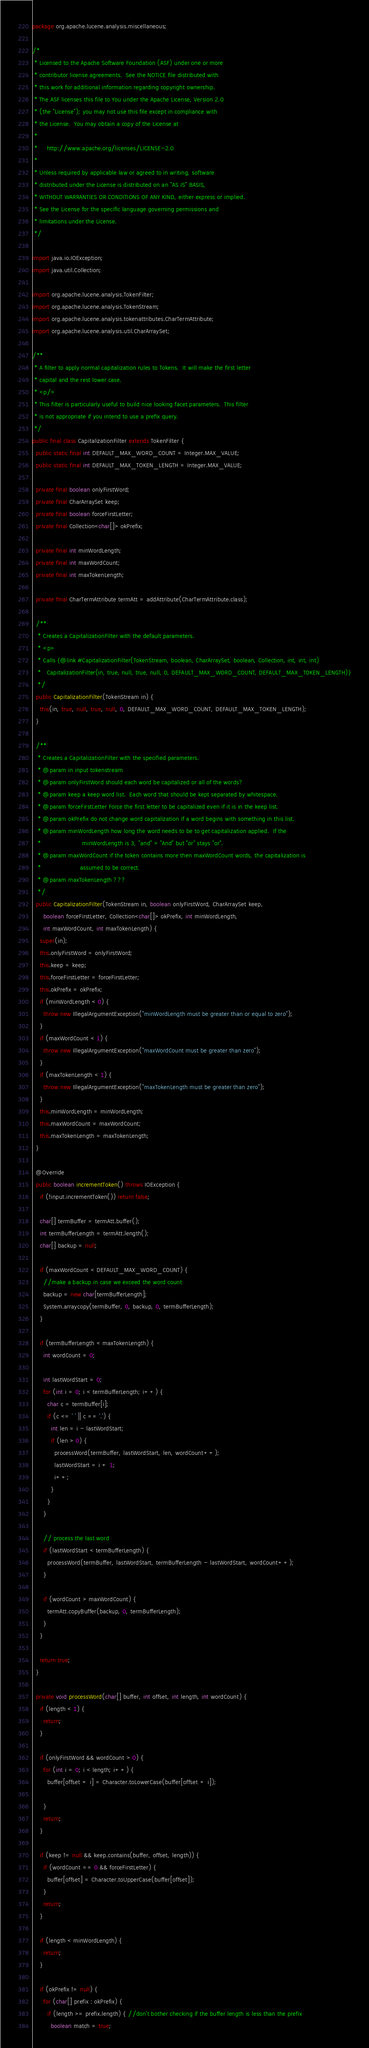Convert code to text. <code><loc_0><loc_0><loc_500><loc_500><_Java_>package org.apache.lucene.analysis.miscellaneous;

/*
 * Licensed to the Apache Software Foundation (ASF) under one or more
 * contributor license agreements.  See the NOTICE file distributed with
 * this work for additional information regarding copyright ownership.
 * The ASF licenses this file to You under the Apache License, Version 2.0
 * (the "License"); you may not use this file except in compliance with
 * the License.  You may obtain a copy of the License at
 *
 *     http://www.apache.org/licenses/LICENSE-2.0
 *
 * Unless required by applicable law or agreed to in writing, software
 * distributed under the License is distributed on an "AS IS" BASIS,
 * WITHOUT WARRANTIES OR CONDITIONS OF ANY KIND, either express or implied.
 * See the License for the specific language governing permissions and
 * limitations under the License.
 */

import java.io.IOException;
import java.util.Collection;

import org.apache.lucene.analysis.TokenFilter;
import org.apache.lucene.analysis.TokenStream;
import org.apache.lucene.analysis.tokenattributes.CharTermAttribute;
import org.apache.lucene.analysis.util.CharArraySet;

/** 
 * A filter to apply normal capitalization rules to Tokens.  It will make the first letter
 * capital and the rest lower case.
 * <p/>
 * This filter is particularly useful to build nice looking facet parameters.  This filter
 * is not appropriate if you intend to use a prefix query.
 */
public final class CapitalizationFilter extends TokenFilter {
  public static final int DEFAULT_MAX_WORD_COUNT = Integer.MAX_VALUE;
  public static final int DEFAULT_MAX_TOKEN_LENGTH = Integer.MAX_VALUE;
  
  private final boolean onlyFirstWord;
  private final CharArraySet keep;
  private final boolean forceFirstLetter;
  private final Collection<char[]> okPrefix;

  private final int minWordLength;
  private final int maxWordCount;
  private final int maxTokenLength;
  
  private final CharTermAttribute termAtt = addAttribute(CharTermAttribute.class);

  /**
   * Creates a CapitalizationFilter with the default parameters.
   * <p>
   * Calls {@link #CapitalizationFilter(TokenStream, boolean, CharArraySet, boolean, Collection, int, int, int)
   *   CapitalizationFilter(in, true, null, true, null, 0, DEFAULT_MAX_WORD_COUNT, DEFAULT_MAX_TOKEN_LENGTH)}
   */
  public CapitalizationFilter(TokenStream in) {
    this(in, true, null, true, null, 0, DEFAULT_MAX_WORD_COUNT, DEFAULT_MAX_TOKEN_LENGTH);
  }
  
  /**
   * Creates a CapitalizationFilter with the specified parameters.
   * @param in input tokenstream 
   * @param onlyFirstWord should each word be capitalized or all of the words?
   * @param keep a keep word list.  Each word that should be kept separated by whitespace.
   * @param forceFirstLetter Force the first letter to be capitalized even if it is in the keep list.
   * @param okPrefix do not change word capitalization if a word begins with something in this list.
   * @param minWordLength how long the word needs to be to get capitalization applied.  If the
   *                      minWordLength is 3, "and" > "And" but "or" stays "or".
   * @param maxWordCount if the token contains more then maxWordCount words, the capitalization is
   *                     assumed to be correct.
   * @param maxTokenLength ???
   */
  public CapitalizationFilter(TokenStream in, boolean onlyFirstWord, CharArraySet keep, 
      boolean forceFirstLetter, Collection<char[]> okPrefix, int minWordLength, 
      int maxWordCount, int maxTokenLength) {
    super(in);
    this.onlyFirstWord = onlyFirstWord;
    this.keep = keep;
    this.forceFirstLetter = forceFirstLetter;
    this.okPrefix = okPrefix;
    if (minWordLength < 0) {
      throw new IllegalArgumentException("minWordLength must be greater than or equal to zero");
    }
    if (maxWordCount < 1) {
      throw new IllegalArgumentException("maxWordCount must be greater than zero");
    }
    if (maxTokenLength < 1) {
      throw new IllegalArgumentException("maxTokenLength must be greater than zero");
    }
    this.minWordLength = minWordLength;
    this.maxWordCount = maxWordCount;
    this.maxTokenLength = maxTokenLength;
  }

  @Override
  public boolean incrementToken() throws IOException {
    if (!input.incrementToken()) return false;

    char[] termBuffer = termAtt.buffer();
    int termBufferLength = termAtt.length();
    char[] backup = null;
    
    if (maxWordCount < DEFAULT_MAX_WORD_COUNT) {
      //make a backup in case we exceed the word count
      backup = new char[termBufferLength];
      System.arraycopy(termBuffer, 0, backup, 0, termBufferLength);
    }
    
    if (termBufferLength < maxTokenLength) {
      int wordCount = 0;

      int lastWordStart = 0;
      for (int i = 0; i < termBufferLength; i++) {
        char c = termBuffer[i];
        if (c <= ' ' || c == '.') {
          int len = i - lastWordStart;
          if (len > 0) {
            processWord(termBuffer, lastWordStart, len, wordCount++);
            lastWordStart = i + 1;
            i++;
          }
        }
      }

      // process the last word
      if (lastWordStart < termBufferLength) {
        processWord(termBuffer, lastWordStart, termBufferLength - lastWordStart, wordCount++);
      }

      if (wordCount > maxWordCount) {
        termAtt.copyBuffer(backup, 0, termBufferLength);
      }
    }

    return true;
  }
  
  private void processWord(char[] buffer, int offset, int length, int wordCount) {
    if (length < 1) {
      return;
    }
    
    if (onlyFirstWord && wordCount > 0) {
      for (int i = 0; i < length; i++) {
        buffer[offset + i] = Character.toLowerCase(buffer[offset + i]);

      }
      return;
    }

    if (keep != null && keep.contains(buffer, offset, length)) {
      if (wordCount == 0 && forceFirstLetter) {
        buffer[offset] = Character.toUpperCase(buffer[offset]);
      }
      return;
    }
    
    if (length < minWordLength) {
      return;
    }
    
    if (okPrefix != null) {
      for (char[] prefix : okPrefix) {
        if (length >= prefix.length) { //don't bother checking if the buffer length is less than the prefix
          boolean match = true;</code> 